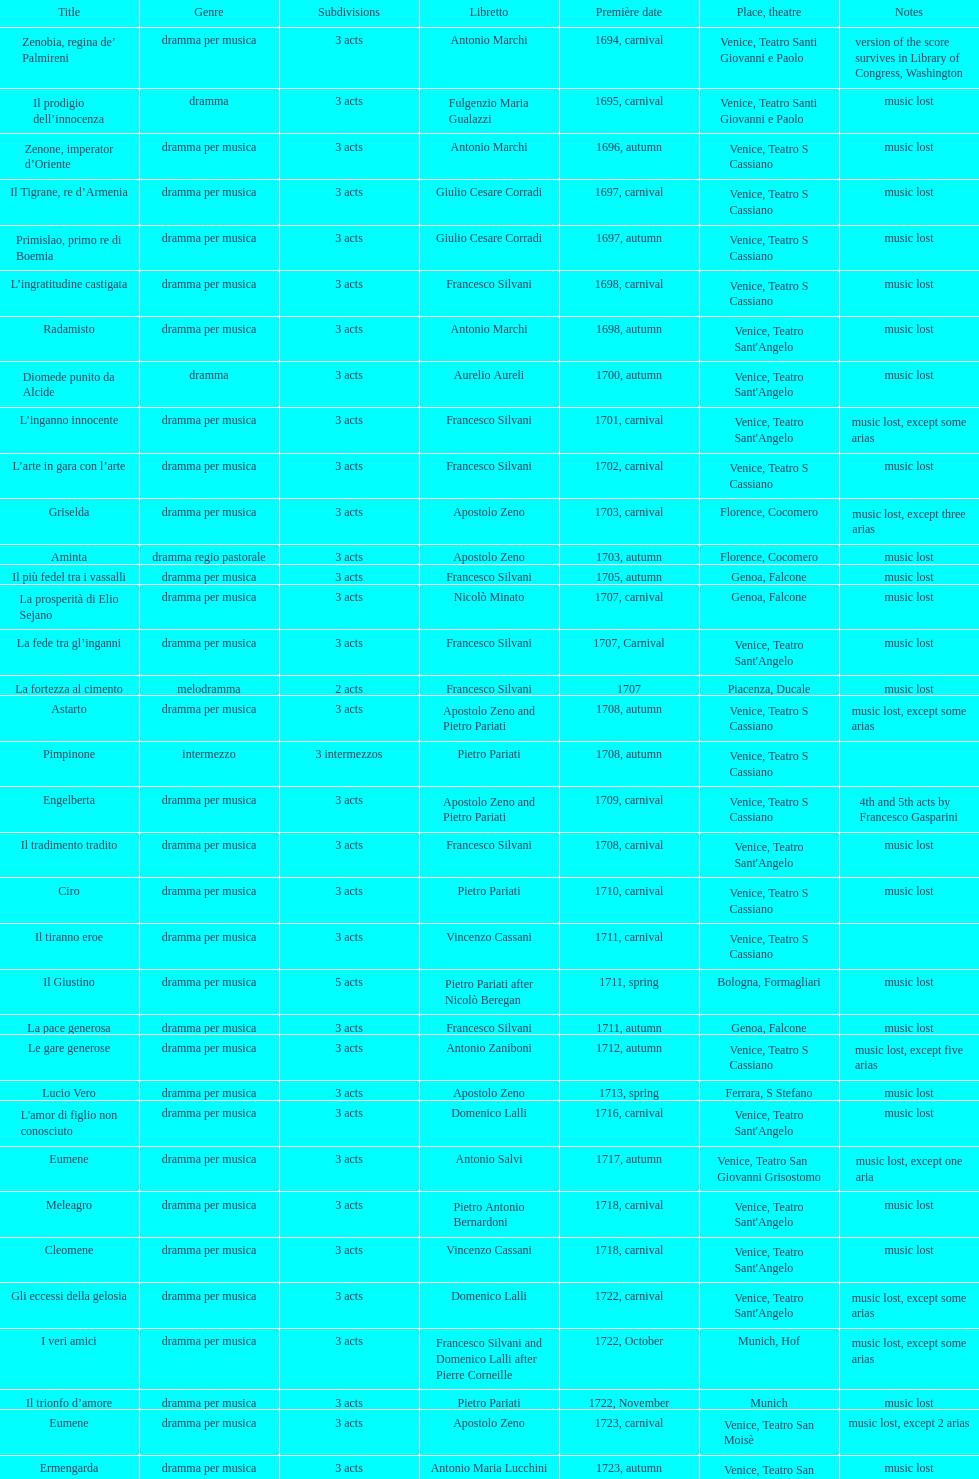How many were set free post zenone, imperator d'oriente? 52. 